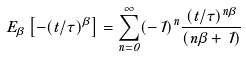<formula> <loc_0><loc_0><loc_500><loc_500>E _ { \beta } \left [ - ( t / \tau ) ^ { \beta } \right ] = \sum _ { n = 0 } ^ { \infty } ( - 1 ) ^ { n } \frac { ( t / \tau ) ^ { n \beta } } { \Gamma ( n \beta + 1 ) }</formula> 